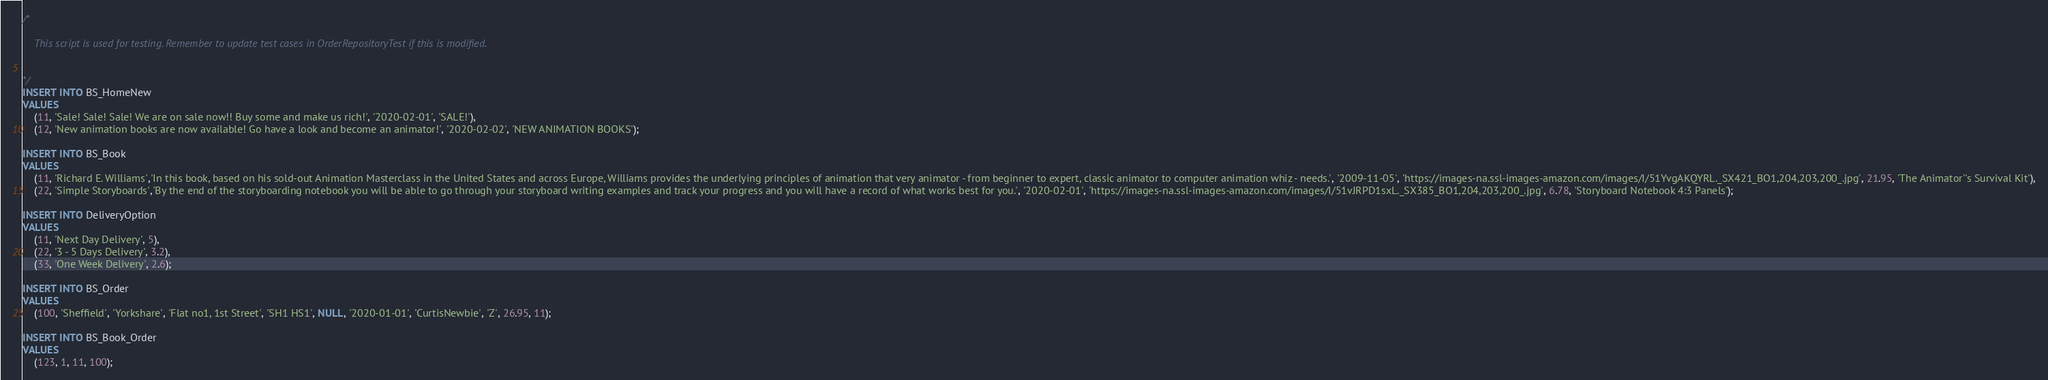<code> <loc_0><loc_0><loc_500><loc_500><_SQL_>/*

    This script is used for testing. Remember to update test cases in OrderRepositoryTest if this is modified.


*/
INSERT INTO BS_HomeNew 
VALUES 
    (11, 'Sale! Sale! Sale! We are on sale now!! Buy some and make us rich!', '2020-02-01', 'SALE!'),
    (12, 'New animation books are now available! Go have a look and become an animator!', '2020-02-02', 'NEW ANIMATION BOOKS');

INSERT INTO BS_Book 
VALUES 
    (11, 'Richard E. Williams','In this book, based on his sold-out Animation Masterclass in the United States and across Europe, Williams provides the underlying principles of animation that very animator - from beginner to expert, classic animator to computer animation whiz - needs.', '2009-11-05', 'https://images-na.ssl-images-amazon.com/images/I/51YvgAKQYRL._SX421_BO1,204,203,200_.jpg', 21.95, 'The Animator''s Survival Kit'),
    (22, 'Simple Storyboards','By the end of the storyboarding notebook you will be able to go through your storyboard writing examples and track your progress and you will have a record of what works best for you.', '2020-02-01', 'https://images-na.ssl-images-amazon.com/images/I/51vJRPD1sxL._SX385_BO1,204,203,200_.jpg', 6.78, 'Storyboard Notebook 4:3 Panels');

INSERT INTO DeliveryOption
VALUES
    (11, 'Next Day Delivery', 5),
    (22, '3 - 5 Days Delivery', 3.2),
    (33, 'One Week Delivery', 2.6);

INSERT INTO BS_Order
VALUES
    (100, 'Sheffield', 'Yorkshare', 'Flat no1, 1st Street', 'SH1 HS1', NULL, '2020-01-01', 'CurtisNewbie', 'Z', 26.95, 11);

INSERT INTO BS_Book_Order
VALUES
    (123, 1, 11, 100);

</code> 